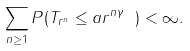<formula> <loc_0><loc_0><loc_500><loc_500>\sum _ { n \geq 1 } P ( T _ { r ^ { n } } \leq a r ^ { n \gamma } \text { } ) < \infty .</formula> 